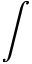<formula> <loc_0><loc_0><loc_500><loc_500>\int</formula> 